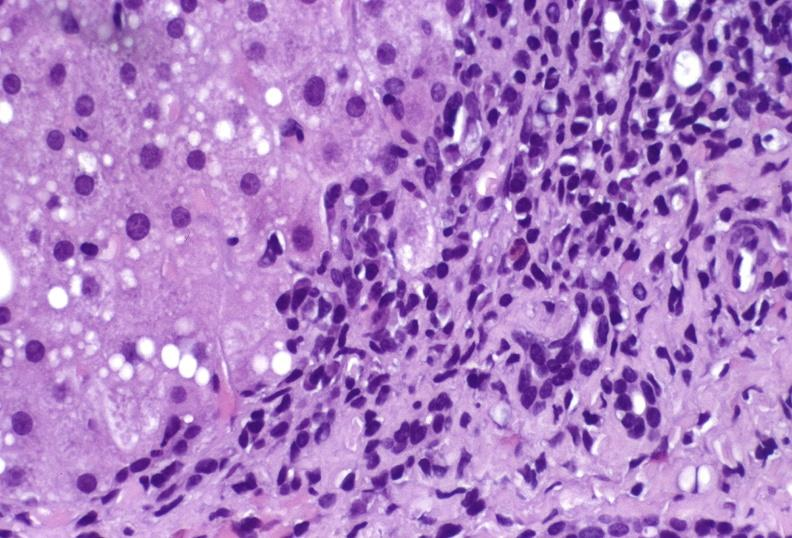s liver present?
Answer the question using a single word or phrase. Yes 